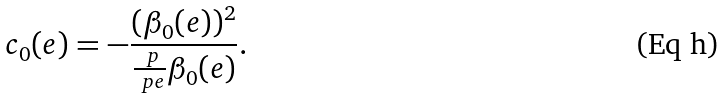Convert formula to latex. <formula><loc_0><loc_0><loc_500><loc_500>c _ { 0 } ( e ) = - \frac { ( \beta _ { 0 } ( e ) ) ^ { 2 } } { \frac { \ p } { \ p e } \beta _ { 0 } ( e ) } .</formula> 